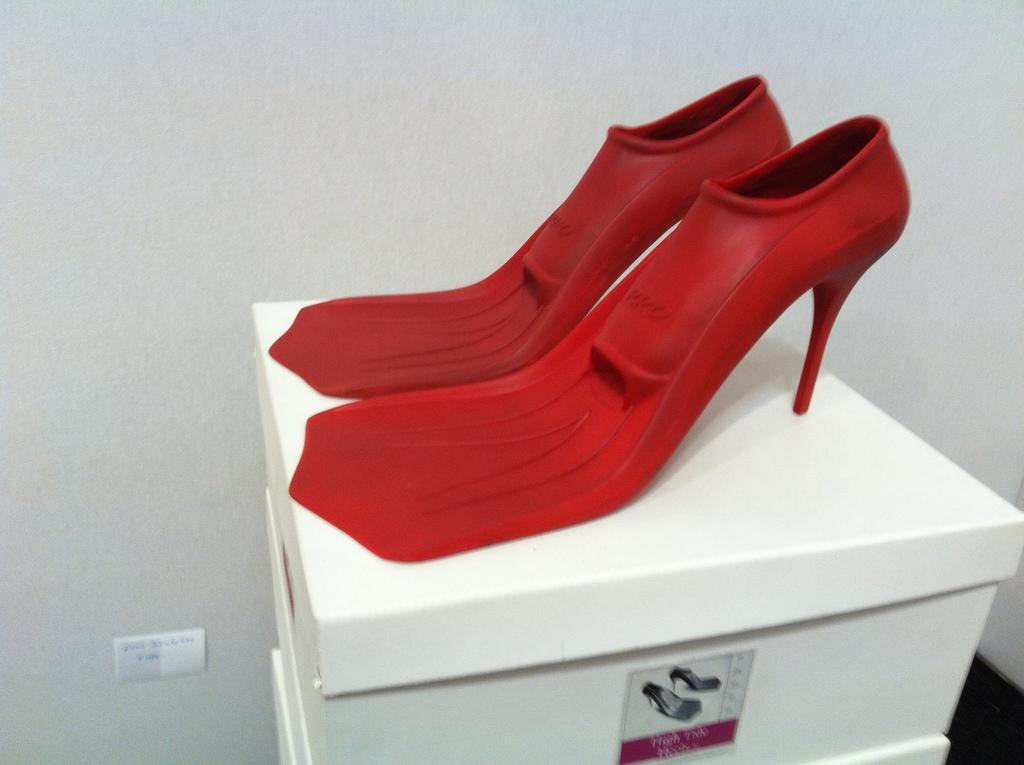What type of footwear is visible in the image? There are sandals in the image. What color are the sandals? The sandals are red in color. What other objects can be seen in the image? There are boxes in the image. What color are the boxes? The boxes are white in color. How does the experience of wearing the sandals affect the end result of the image? The image does not depict anyone wearing the sandals, so there is no experience of wearing them to affect the end result of the image. 